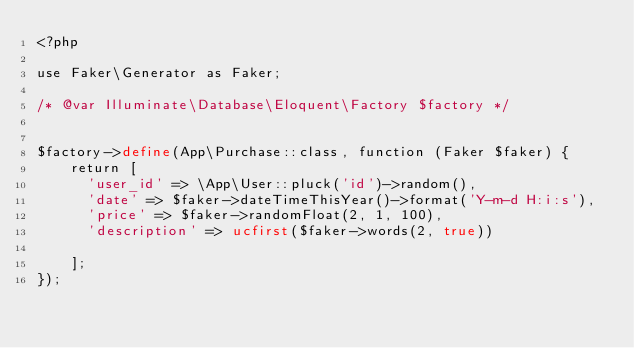<code> <loc_0><loc_0><loc_500><loc_500><_PHP_><?php

use Faker\Generator as Faker;

/* @var Illuminate\Database\Eloquent\Factory $factory */


$factory->define(App\Purchase::class, function (Faker $faker) {
    return [
      'user_id' => \App\User::pluck('id')->random(),
      'date' => $faker->dateTimeThisYear()->format('Y-m-d H:i:s'),
      'price' => $faker->randomFloat(2, 1, 100),
      'description' => ucfirst($faker->words(2, true))

    ];
});
</code> 